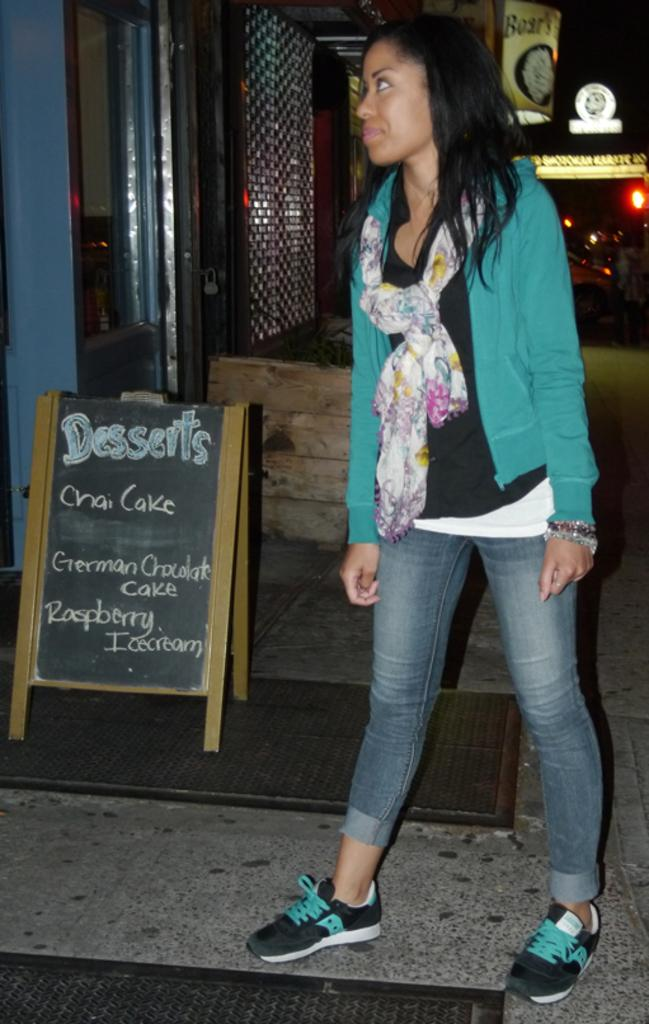What type of structure can be seen in the image? There is a wall in the image. What is another object that can be seen in the image? There is a mirror in the image. What additional item is present in the image? There is a banner in the image. Are there any light sources visible in the image? Yes, there are lights in the image. Who is present in the image? There is a woman standing in the image. What type of soup is being served in the image? There is no soup present in the image. What nerve is being stimulated by the woman in the image? There is no mention of a nerve or any medical procedure in the image. 